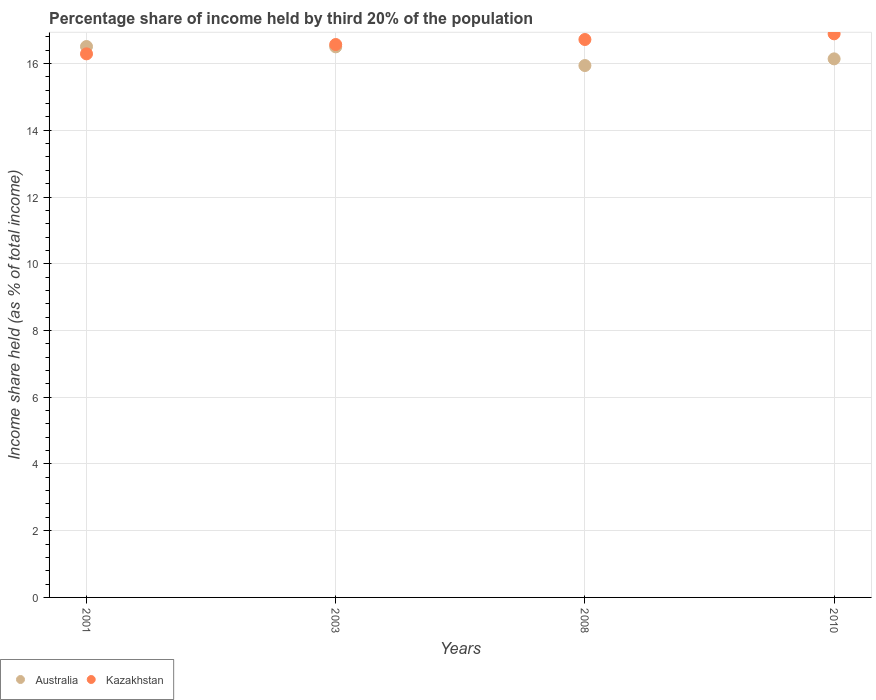What is the share of income held by third 20% of the population in Kazakhstan in 2010?
Make the answer very short. 16.89. Across all years, what is the maximum share of income held by third 20% of the population in Kazakhstan?
Provide a succinct answer. 16.89. Across all years, what is the minimum share of income held by third 20% of the population in Australia?
Provide a short and direct response. 15.94. In which year was the share of income held by third 20% of the population in Australia maximum?
Make the answer very short. 2001. What is the total share of income held by third 20% of the population in Australia in the graph?
Make the answer very short. 65.09. What is the difference between the share of income held by third 20% of the population in Kazakhstan in 2003 and that in 2010?
Offer a terse response. -0.32. What is the difference between the share of income held by third 20% of the population in Kazakhstan in 2003 and the share of income held by third 20% of the population in Australia in 2008?
Keep it short and to the point. 0.63. What is the average share of income held by third 20% of the population in Kazakhstan per year?
Your answer should be very brief. 16.62. In the year 2001, what is the difference between the share of income held by third 20% of the population in Kazakhstan and share of income held by third 20% of the population in Australia?
Your answer should be compact. -0.22. In how many years, is the share of income held by third 20% of the population in Australia greater than 7.2 %?
Provide a short and direct response. 4. What is the ratio of the share of income held by third 20% of the population in Australia in 2001 to that in 2008?
Offer a terse response. 1.04. Is the share of income held by third 20% of the population in Kazakhstan in 2001 less than that in 2008?
Provide a short and direct response. Yes. What is the difference between the highest and the second highest share of income held by third 20% of the population in Australia?
Ensure brevity in your answer.  0.01. What is the difference between the highest and the lowest share of income held by third 20% of the population in Kazakhstan?
Your answer should be compact. 0.6. Is the sum of the share of income held by third 20% of the population in Australia in 2003 and 2010 greater than the maximum share of income held by third 20% of the population in Kazakhstan across all years?
Offer a terse response. Yes. Does the share of income held by third 20% of the population in Australia monotonically increase over the years?
Make the answer very short. No. Is the share of income held by third 20% of the population in Kazakhstan strictly less than the share of income held by third 20% of the population in Australia over the years?
Give a very brief answer. No. How many dotlines are there?
Your answer should be very brief. 2. Are the values on the major ticks of Y-axis written in scientific E-notation?
Give a very brief answer. No. Does the graph contain any zero values?
Your answer should be compact. No. Where does the legend appear in the graph?
Offer a very short reply. Bottom left. What is the title of the graph?
Make the answer very short. Percentage share of income held by third 20% of the population. What is the label or title of the Y-axis?
Ensure brevity in your answer.  Income share held (as % of total income). What is the Income share held (as % of total income) of Australia in 2001?
Make the answer very short. 16.51. What is the Income share held (as % of total income) in Kazakhstan in 2001?
Give a very brief answer. 16.29. What is the Income share held (as % of total income) in Kazakhstan in 2003?
Your answer should be compact. 16.57. What is the Income share held (as % of total income) of Australia in 2008?
Give a very brief answer. 15.94. What is the Income share held (as % of total income) of Kazakhstan in 2008?
Offer a terse response. 16.72. What is the Income share held (as % of total income) of Australia in 2010?
Your response must be concise. 16.14. What is the Income share held (as % of total income) in Kazakhstan in 2010?
Your response must be concise. 16.89. Across all years, what is the maximum Income share held (as % of total income) in Australia?
Your answer should be very brief. 16.51. Across all years, what is the maximum Income share held (as % of total income) of Kazakhstan?
Your answer should be compact. 16.89. Across all years, what is the minimum Income share held (as % of total income) in Australia?
Provide a succinct answer. 15.94. Across all years, what is the minimum Income share held (as % of total income) of Kazakhstan?
Make the answer very short. 16.29. What is the total Income share held (as % of total income) of Australia in the graph?
Give a very brief answer. 65.09. What is the total Income share held (as % of total income) in Kazakhstan in the graph?
Offer a very short reply. 66.47. What is the difference between the Income share held (as % of total income) of Kazakhstan in 2001 and that in 2003?
Your answer should be compact. -0.28. What is the difference between the Income share held (as % of total income) in Australia in 2001 and that in 2008?
Keep it short and to the point. 0.57. What is the difference between the Income share held (as % of total income) in Kazakhstan in 2001 and that in 2008?
Your response must be concise. -0.43. What is the difference between the Income share held (as % of total income) of Australia in 2001 and that in 2010?
Your response must be concise. 0.37. What is the difference between the Income share held (as % of total income) in Kazakhstan in 2001 and that in 2010?
Ensure brevity in your answer.  -0.6. What is the difference between the Income share held (as % of total income) of Australia in 2003 and that in 2008?
Ensure brevity in your answer.  0.56. What is the difference between the Income share held (as % of total income) in Kazakhstan in 2003 and that in 2008?
Offer a terse response. -0.15. What is the difference between the Income share held (as % of total income) of Australia in 2003 and that in 2010?
Give a very brief answer. 0.36. What is the difference between the Income share held (as % of total income) of Kazakhstan in 2003 and that in 2010?
Offer a terse response. -0.32. What is the difference between the Income share held (as % of total income) in Australia in 2008 and that in 2010?
Keep it short and to the point. -0.2. What is the difference between the Income share held (as % of total income) in Kazakhstan in 2008 and that in 2010?
Provide a short and direct response. -0.17. What is the difference between the Income share held (as % of total income) of Australia in 2001 and the Income share held (as % of total income) of Kazakhstan in 2003?
Your answer should be compact. -0.06. What is the difference between the Income share held (as % of total income) of Australia in 2001 and the Income share held (as % of total income) of Kazakhstan in 2008?
Provide a succinct answer. -0.21. What is the difference between the Income share held (as % of total income) in Australia in 2001 and the Income share held (as % of total income) in Kazakhstan in 2010?
Your response must be concise. -0.38. What is the difference between the Income share held (as % of total income) in Australia in 2003 and the Income share held (as % of total income) in Kazakhstan in 2008?
Offer a terse response. -0.22. What is the difference between the Income share held (as % of total income) of Australia in 2003 and the Income share held (as % of total income) of Kazakhstan in 2010?
Keep it short and to the point. -0.39. What is the difference between the Income share held (as % of total income) in Australia in 2008 and the Income share held (as % of total income) in Kazakhstan in 2010?
Provide a short and direct response. -0.95. What is the average Income share held (as % of total income) in Australia per year?
Your answer should be compact. 16.27. What is the average Income share held (as % of total income) in Kazakhstan per year?
Offer a very short reply. 16.62. In the year 2001, what is the difference between the Income share held (as % of total income) of Australia and Income share held (as % of total income) of Kazakhstan?
Ensure brevity in your answer.  0.22. In the year 2003, what is the difference between the Income share held (as % of total income) of Australia and Income share held (as % of total income) of Kazakhstan?
Your answer should be very brief. -0.07. In the year 2008, what is the difference between the Income share held (as % of total income) of Australia and Income share held (as % of total income) of Kazakhstan?
Keep it short and to the point. -0.78. In the year 2010, what is the difference between the Income share held (as % of total income) in Australia and Income share held (as % of total income) in Kazakhstan?
Your answer should be very brief. -0.75. What is the ratio of the Income share held (as % of total income) of Australia in 2001 to that in 2003?
Ensure brevity in your answer.  1. What is the ratio of the Income share held (as % of total income) in Kazakhstan in 2001 to that in 2003?
Keep it short and to the point. 0.98. What is the ratio of the Income share held (as % of total income) of Australia in 2001 to that in 2008?
Provide a succinct answer. 1.04. What is the ratio of the Income share held (as % of total income) of Kazakhstan in 2001 to that in 2008?
Keep it short and to the point. 0.97. What is the ratio of the Income share held (as % of total income) in Australia in 2001 to that in 2010?
Make the answer very short. 1.02. What is the ratio of the Income share held (as % of total income) of Kazakhstan in 2001 to that in 2010?
Keep it short and to the point. 0.96. What is the ratio of the Income share held (as % of total income) in Australia in 2003 to that in 2008?
Keep it short and to the point. 1.04. What is the ratio of the Income share held (as % of total income) of Australia in 2003 to that in 2010?
Offer a terse response. 1.02. What is the ratio of the Income share held (as % of total income) of Kazakhstan in 2003 to that in 2010?
Ensure brevity in your answer.  0.98. What is the ratio of the Income share held (as % of total income) in Australia in 2008 to that in 2010?
Ensure brevity in your answer.  0.99. What is the ratio of the Income share held (as % of total income) of Kazakhstan in 2008 to that in 2010?
Provide a short and direct response. 0.99. What is the difference between the highest and the second highest Income share held (as % of total income) of Australia?
Offer a very short reply. 0.01. What is the difference between the highest and the second highest Income share held (as % of total income) of Kazakhstan?
Keep it short and to the point. 0.17. What is the difference between the highest and the lowest Income share held (as % of total income) of Australia?
Give a very brief answer. 0.57. 